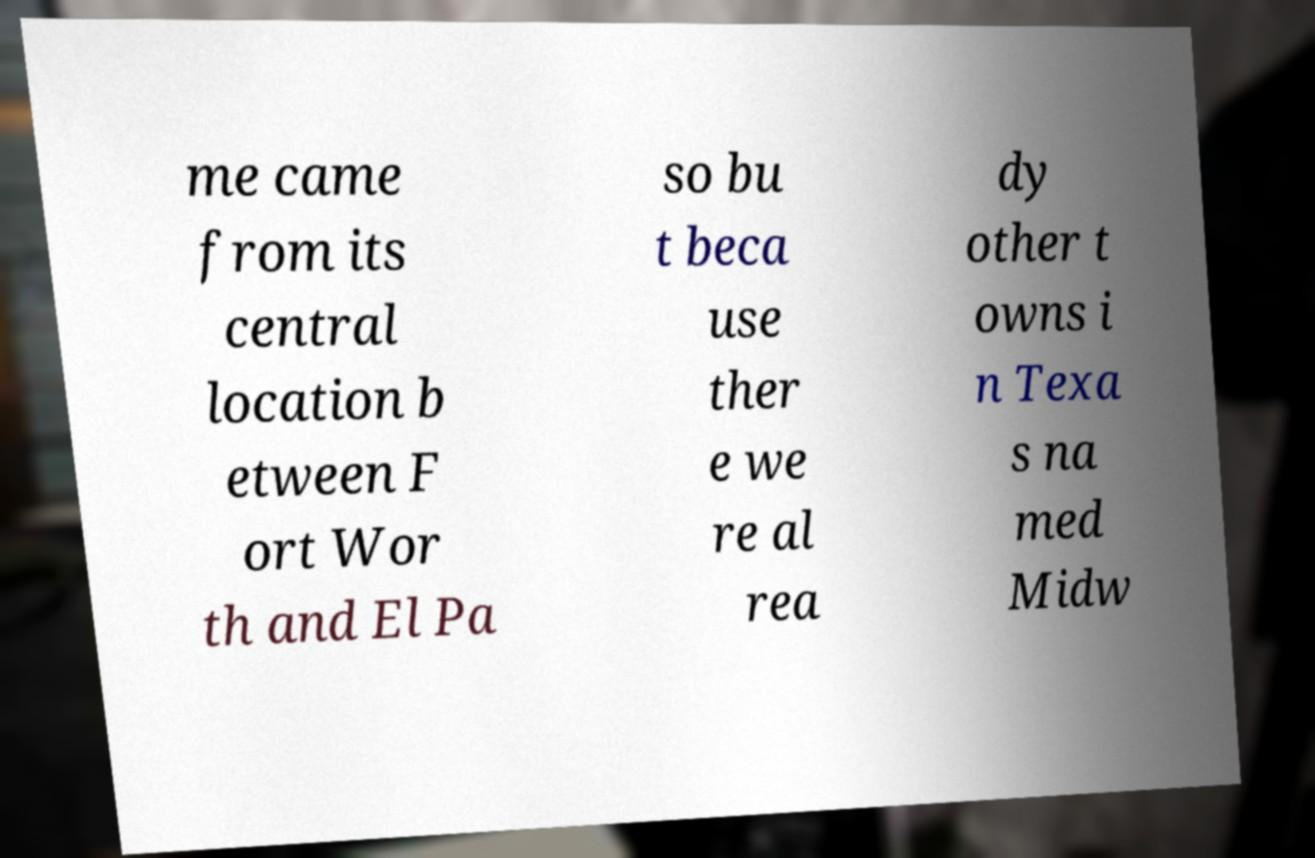Could you assist in decoding the text presented in this image and type it out clearly? me came from its central location b etween F ort Wor th and El Pa so bu t beca use ther e we re al rea dy other t owns i n Texa s na med Midw 